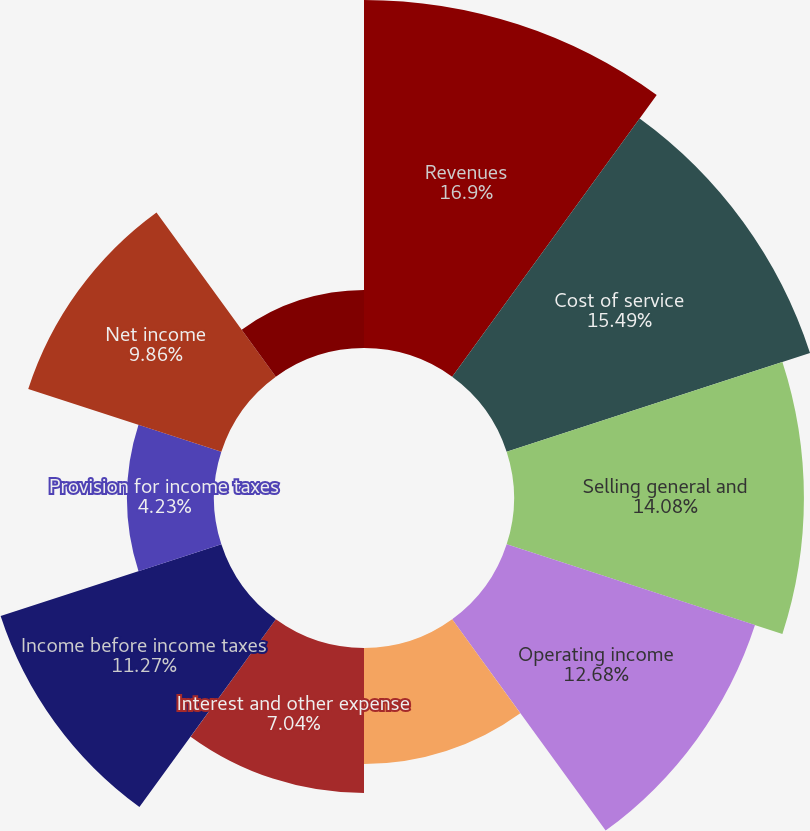Convert chart. <chart><loc_0><loc_0><loc_500><loc_500><pie_chart><fcel>Revenues<fcel>Cost of service<fcel>Selling general and<fcel>Operating income<fcel>Interest and other income<fcel>Interest and other expense<fcel>Income before income taxes<fcel>Provision for income taxes<fcel>Net income<fcel>Less Net income attributable<nl><fcel>16.9%<fcel>15.49%<fcel>14.08%<fcel>12.68%<fcel>5.63%<fcel>7.04%<fcel>11.27%<fcel>4.23%<fcel>9.86%<fcel>2.82%<nl></chart> 